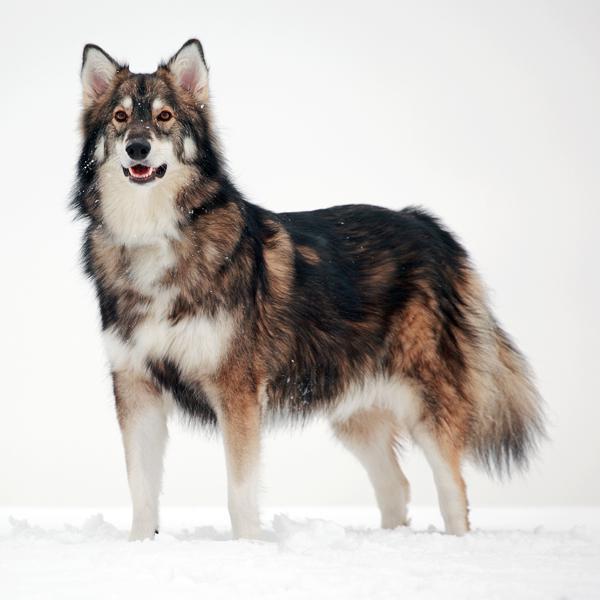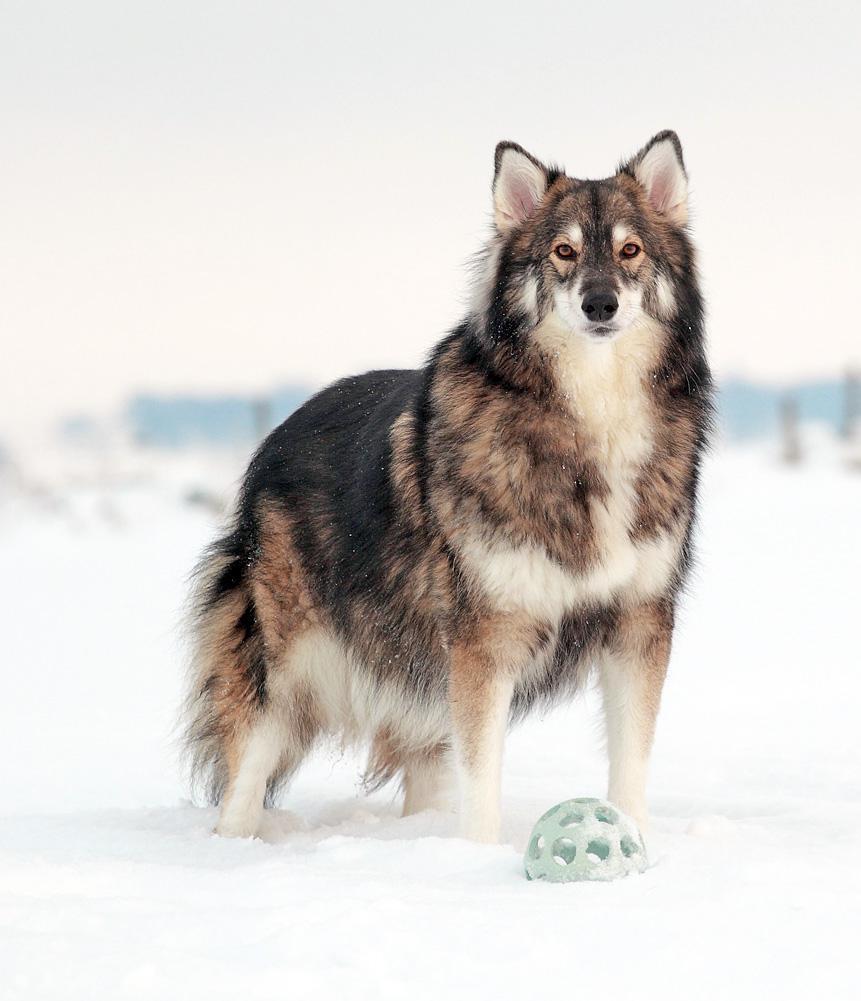The first image is the image on the left, the second image is the image on the right. Analyze the images presented: Is the assertion "The left and right image contains the same number of dogs pointed in opposite directions." valid? Answer yes or no. Yes. The first image is the image on the left, the second image is the image on the right. For the images shown, is this caption "Two dogs are in snow." true? Answer yes or no. Yes. 